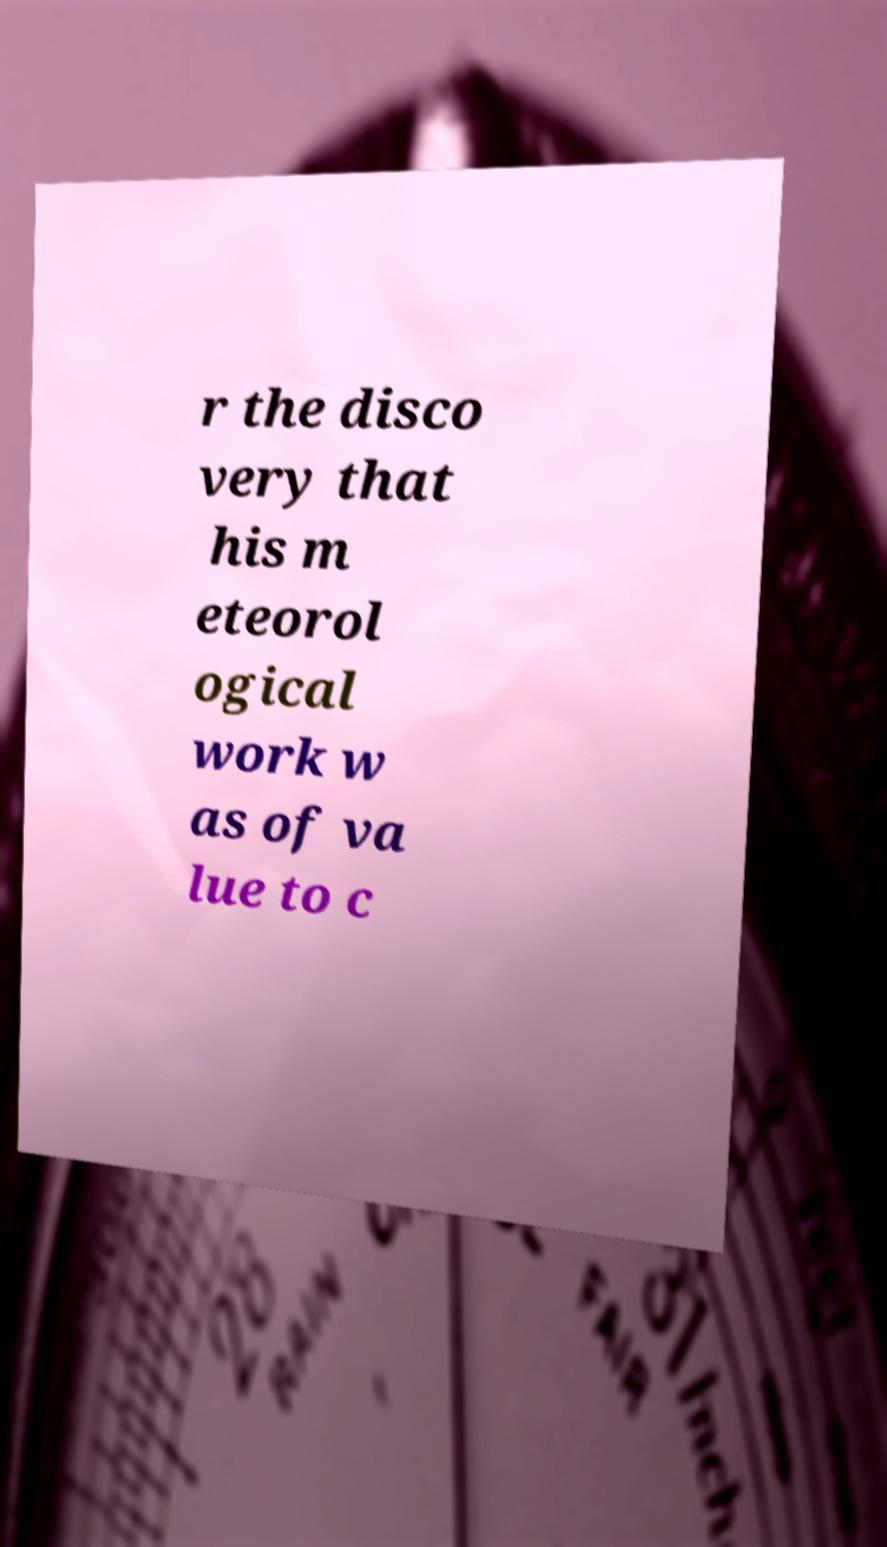Can you read and provide the text displayed in the image?This photo seems to have some interesting text. Can you extract and type it out for me? r the disco very that his m eteorol ogical work w as of va lue to c 